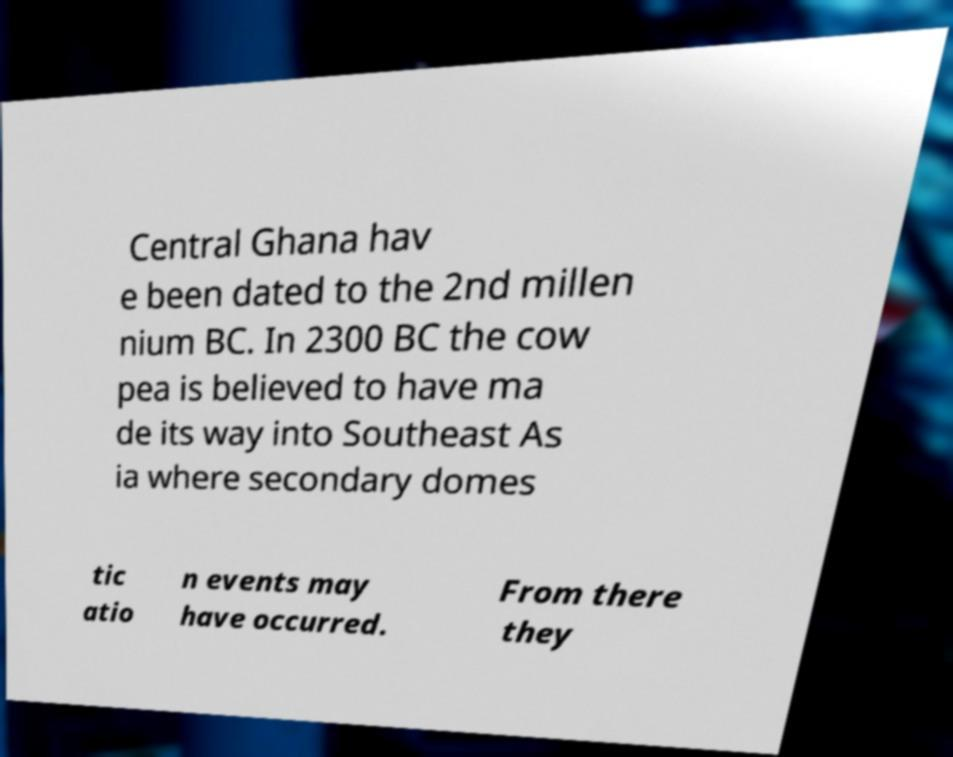Could you extract and type out the text from this image? Central Ghana hav e been dated to the 2nd millen nium BC. In 2300 BC the cow pea is believed to have ma de its way into Southeast As ia where secondary domes tic atio n events may have occurred. From there they 